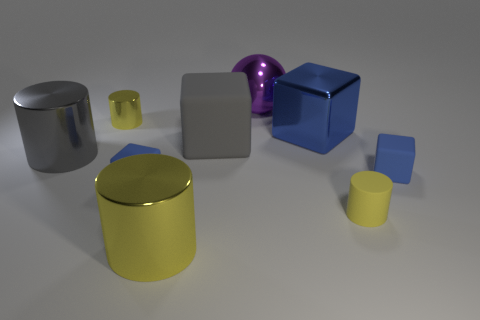Is the color of the small cylinder left of the rubber cylinder the same as the tiny matte cylinder?
Offer a very short reply. Yes. Is there a big blue cylinder that has the same material as the large yellow object?
Provide a succinct answer. No. Are there fewer big purple shiny objects on the right side of the large matte block than small red balls?
Offer a very short reply. No. There is a metal thing on the right side of the purple metallic object; is it the same size as the tiny yellow matte object?
Make the answer very short. No. What number of purple metallic things are the same shape as the big gray metal object?
Make the answer very short. 0. The gray cylinder that is the same material as the large blue cube is what size?
Ensure brevity in your answer.  Large. Is the number of big rubber objects in front of the gray metallic cylinder the same as the number of yellow cylinders?
Your response must be concise. No. Does the tiny metallic object have the same color as the rubber cylinder?
Ensure brevity in your answer.  Yes. Is the shape of the small matte object that is right of the yellow rubber cylinder the same as the blue thing to the left of the big blue object?
Your response must be concise. Yes. There is a large blue thing that is the same shape as the gray rubber object; what is it made of?
Provide a short and direct response. Metal. 